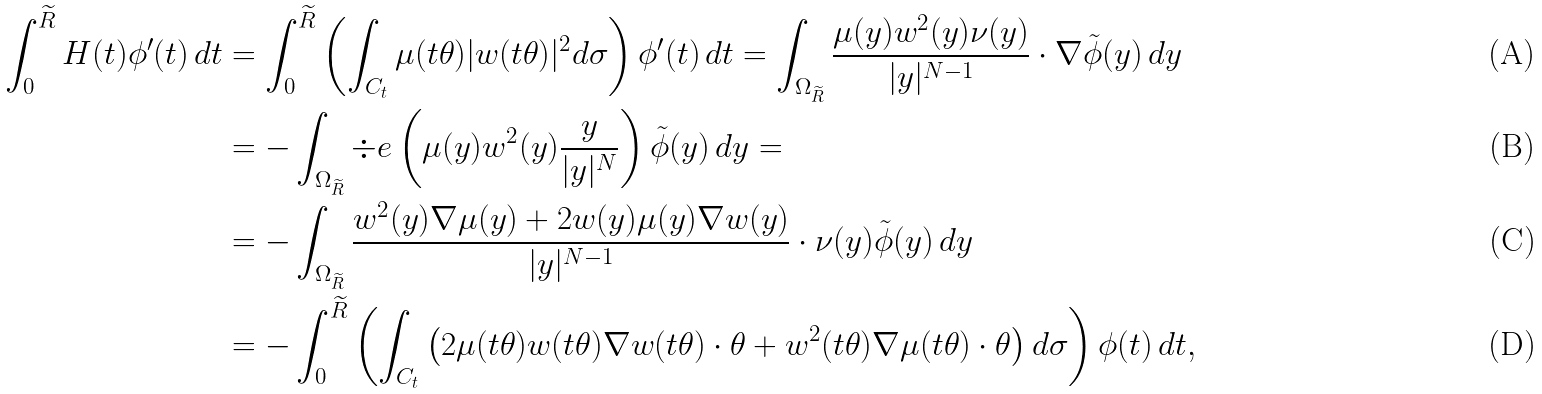Convert formula to latex. <formula><loc_0><loc_0><loc_500><loc_500>\int _ { 0 } ^ { \widetilde { R } } H ( t ) \phi ^ { \prime } ( t ) \, d t & = \int _ { 0 } ^ { \widetilde { R } } \left ( \int _ { C _ { t } } \mu ( t \theta ) | w ( t \theta ) | ^ { 2 } d \sigma \right ) \phi ^ { \prime } ( t ) \, d t = \int _ { \Omega _ { \widetilde { R } } } \frac { \mu ( y ) w ^ { 2 } ( y ) \nu ( y ) } { | y | ^ { N - 1 } } \cdot \nabla \tilde { \phi } ( y ) \, d y \\ & = - \int _ { \Omega _ { \widetilde { R } } } \div e \left ( \mu ( y ) w ^ { 2 } ( y ) \frac { y } { | y | ^ { N } } \right ) \tilde { \phi } ( y ) \, d y = \\ & = - \int _ { \Omega _ { \widetilde { R } } } \frac { w ^ { 2 } ( y ) \nabla \mu ( y ) + 2 w ( y ) \mu ( y ) \nabla w ( y ) } { | y | ^ { N - 1 } } \cdot \nu ( y ) \tilde { \phi } ( y ) \, d y \\ & = - \int _ { 0 } ^ { \widetilde { R } } \left ( \int _ { C _ { t } } \left ( 2 \mu ( t \theta ) w ( t \theta ) \nabla w ( t \theta ) \cdot \theta + w ^ { 2 } ( t \theta ) \nabla \mu ( t \theta ) \cdot \theta \right ) d \sigma \right ) \phi ( t ) \, d t ,</formula> 